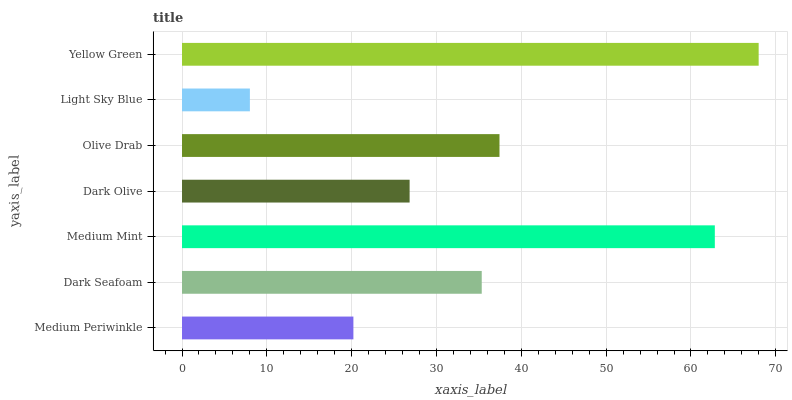Is Light Sky Blue the minimum?
Answer yes or no. Yes. Is Yellow Green the maximum?
Answer yes or no. Yes. Is Dark Seafoam the minimum?
Answer yes or no. No. Is Dark Seafoam the maximum?
Answer yes or no. No. Is Dark Seafoam greater than Medium Periwinkle?
Answer yes or no. Yes. Is Medium Periwinkle less than Dark Seafoam?
Answer yes or no. Yes. Is Medium Periwinkle greater than Dark Seafoam?
Answer yes or no. No. Is Dark Seafoam less than Medium Periwinkle?
Answer yes or no. No. Is Dark Seafoam the high median?
Answer yes or no. Yes. Is Dark Seafoam the low median?
Answer yes or no. Yes. Is Olive Drab the high median?
Answer yes or no. No. Is Medium Mint the low median?
Answer yes or no. No. 